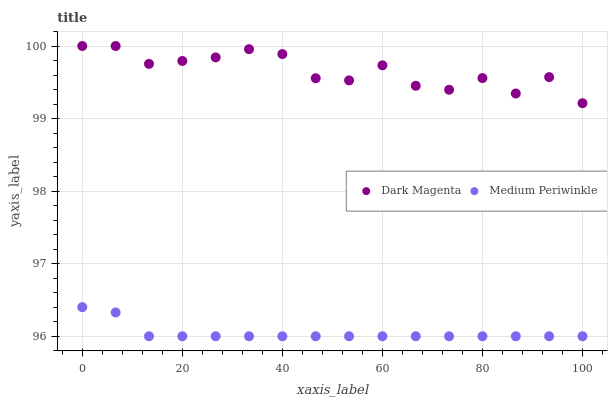Does Medium Periwinkle have the minimum area under the curve?
Answer yes or no. Yes. Does Dark Magenta have the maximum area under the curve?
Answer yes or no. Yes. Does Dark Magenta have the minimum area under the curve?
Answer yes or no. No. Is Medium Periwinkle the smoothest?
Answer yes or no. Yes. Is Dark Magenta the roughest?
Answer yes or no. Yes. Is Dark Magenta the smoothest?
Answer yes or no. No. Does Medium Periwinkle have the lowest value?
Answer yes or no. Yes. Does Dark Magenta have the lowest value?
Answer yes or no. No. Does Dark Magenta have the highest value?
Answer yes or no. Yes. Is Medium Periwinkle less than Dark Magenta?
Answer yes or no. Yes. Is Dark Magenta greater than Medium Periwinkle?
Answer yes or no. Yes. Does Medium Periwinkle intersect Dark Magenta?
Answer yes or no. No. 